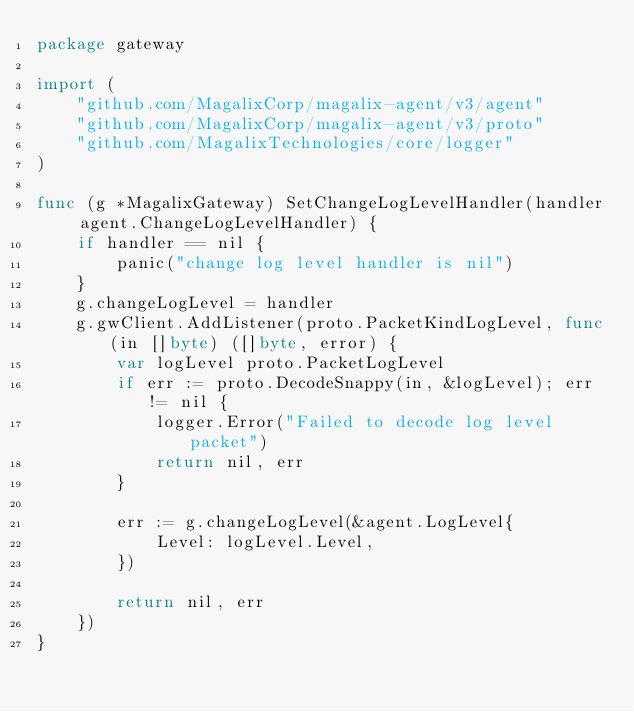Convert code to text. <code><loc_0><loc_0><loc_500><loc_500><_Go_>package gateway

import (
	"github.com/MagalixCorp/magalix-agent/v3/agent"
	"github.com/MagalixCorp/magalix-agent/v3/proto"
	"github.com/MagalixTechnologies/core/logger"
)

func (g *MagalixGateway) SetChangeLogLevelHandler(handler agent.ChangeLogLevelHandler) {
	if handler == nil {
		panic("change log level handler is nil")
	}
	g.changeLogLevel = handler
	g.gwClient.AddListener(proto.PacketKindLogLevel, func(in []byte) ([]byte, error) {
		var logLevel proto.PacketLogLevel
		if err := proto.DecodeSnappy(in, &logLevel); err != nil {
			logger.Error("Failed to decode log level packet")
			return nil, err
		}

		err := g.changeLogLevel(&agent.LogLevel{
			Level: logLevel.Level,
		})

		return nil, err
	})
}
</code> 